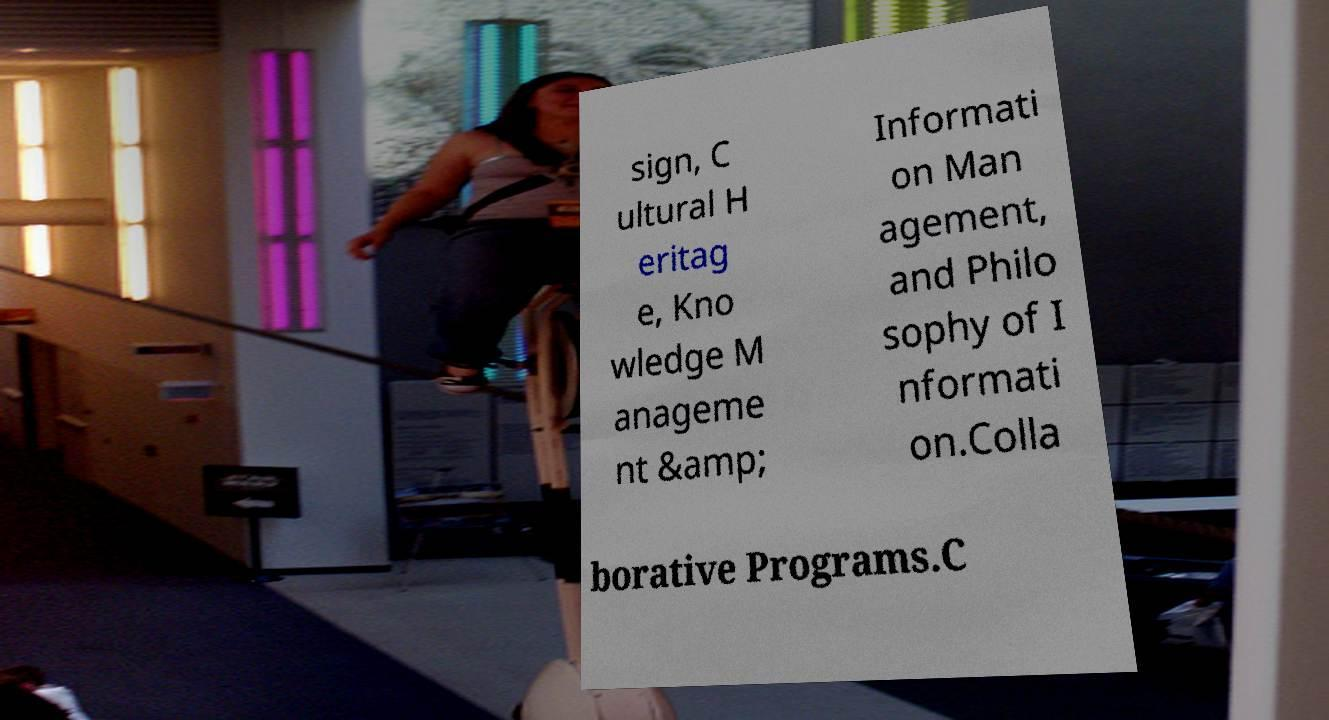I need the written content from this picture converted into text. Can you do that? sign, C ultural H eritag e, Kno wledge M anageme nt &amp; Informati on Man agement, and Philo sophy of I nformati on.Colla borative Programs.C 